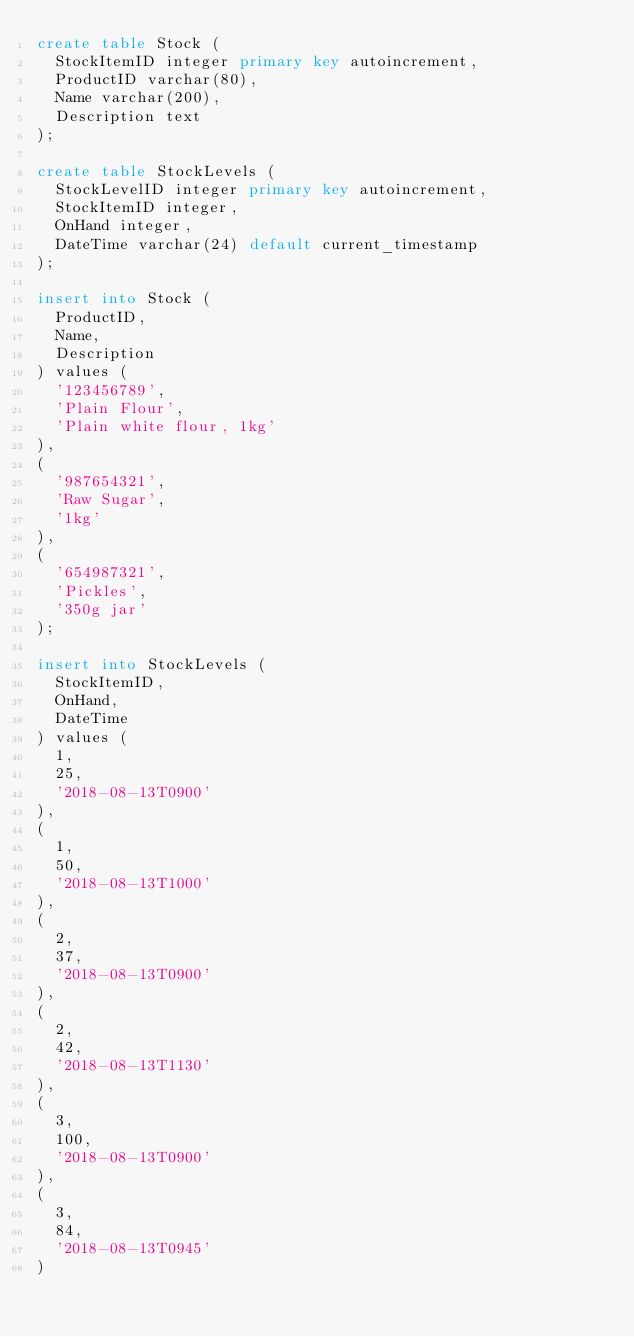Convert code to text. <code><loc_0><loc_0><loc_500><loc_500><_SQL_>create table Stock (
  StockItemID integer primary key autoincrement,
  ProductID varchar(80),
  Name varchar(200),
  Description text
);

create table StockLevels (
  StockLevelID integer primary key autoincrement,
  StockItemID integer,
  OnHand integer,
  DateTime varchar(24) default current_timestamp 
);

insert into Stock (
  ProductID,
  Name,
  Description
) values (
  '123456789',
  'Plain Flour',
  'Plain white flour, 1kg'
),
(
  '987654321',
  'Raw Sugar',
  '1kg'
),
(
  '654987321',
  'Pickles',
  '350g jar'
);

insert into StockLevels (
  StockItemID,
  OnHand,
  DateTime
) values (
  1,
  25,
  '2018-08-13T0900'
),
(
  1,
  50,
  '2018-08-13T1000'
),
(
  2,
  37,
  '2018-08-13T0900'
),
(
  2,
  42,
  '2018-08-13T1130'
),
(
  3,
  100,
  '2018-08-13T0900'
),
(
  3,
  84,
  '2018-08-13T0945'
)</code> 